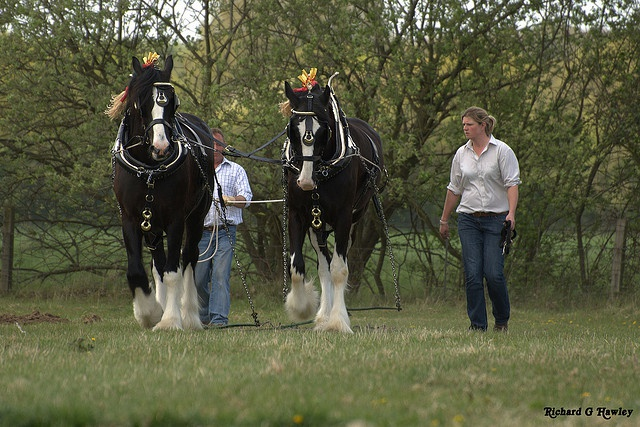Describe the objects in this image and their specific colors. I can see horse in darkgreen, black, gray, and darkgray tones, horse in darkgreen, black, gray, and darkgray tones, people in darkgreen, black, darkgray, gray, and lightgray tones, and people in darkgreen, gray, black, lavender, and darkgray tones in this image. 